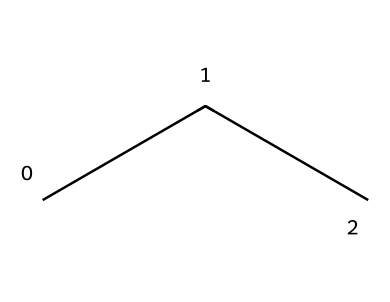What is the molecular formula of propane? The SMILES representation 'CCC' indicates a straight-chain arrangement of three carbon atoms (C) with associated hydrogen (H) atoms. Each carbon atom in propane is bonded to enough hydrogen atoms to satisfy carbon's tetravalency. The molecular formula is derived by counting the number of carbon and hydrogen atoms: C3 and H8.
Answer: C3H8 How many carbon atoms are in propane? The SMILES notation 'CCC' clearly shows three consecutive carbon atoms in a linear arrangement. Counting these gives the number of carbon atoms directly.
Answer: 3 What type of molecular structure does propane have? Propane, represented by 'CCC', has a linear or straight-chain (open-chain) structure since there are no branching or cyclic features visible in the representation. The structure forms a continuous chain, defining its classification as a straight-chain alkane.
Answer: linear What is the primary use of propane in refrigeration? Propane is commonly used in refrigeration systems as a refrigerant due to its low boiling point and efficiency in heat exchange applications. It serves effectively in both commercial and residential refrigeration.
Answer: refrigerant Does propane have double or triple bonds? In the chemical representation 'CCC', each carbon atom is connected by single bonds, with no presence of double or triple bonds. The SMILES notation suggests a saturated hydrocarbon, confirming the absence of these types of bonds.
Answer: no What physical state is propane at room temperature? Propane, being a small hydrocarbon with a molecular formula of C3H8, exists as a gas at room temperature and pressure. However, it can be condensed into a liquid under pressure, which is typical for refrigerants.
Answer: gas What is the significance of propane's Greek-derived name? The name 'propane' originates from the Greek prefix 'pro-', meaning 'first', and 'pane', which references the hydrocarbon's structure with respect to other alkanes. This etymological aspect reflects its position as the first member in the propane family (three carbons in a chain).
Answer: first 